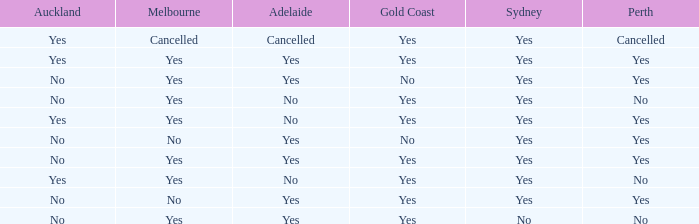What is The Melbourne with a No- Gold Coast Yes, No. 